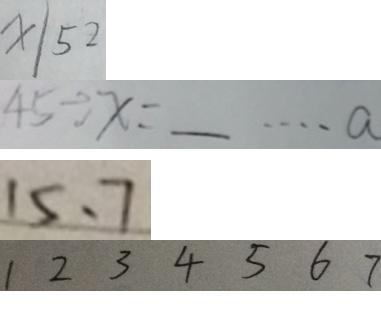Convert formula to latex. <formula><loc_0><loc_0><loc_500><loc_500>x \vert 5 2 
 4 5 \div x = \_ \cdots a 
 1 5 、 7 
 1 2 3 4 5 6 7</formula> 